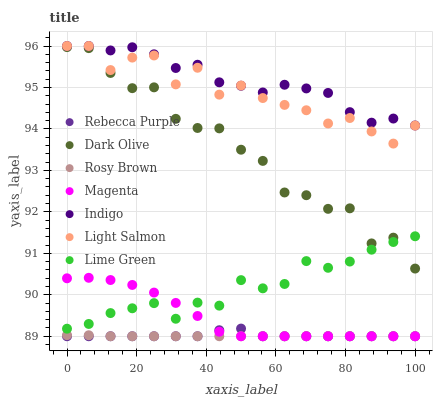Does Rosy Brown have the minimum area under the curve?
Answer yes or no. Yes. Does Indigo have the maximum area under the curve?
Answer yes or no. Yes. Does Dark Olive have the minimum area under the curve?
Answer yes or no. No. Does Dark Olive have the maximum area under the curve?
Answer yes or no. No. Is Rosy Brown the smoothest?
Answer yes or no. Yes. Is Light Salmon the roughest?
Answer yes or no. Yes. Is Dark Olive the smoothest?
Answer yes or no. No. Is Dark Olive the roughest?
Answer yes or no. No. Does Rosy Brown have the lowest value?
Answer yes or no. Yes. Does Dark Olive have the lowest value?
Answer yes or no. No. Does Indigo have the highest value?
Answer yes or no. Yes. Does Dark Olive have the highest value?
Answer yes or no. No. Is Rosy Brown less than Light Salmon?
Answer yes or no. Yes. Is Light Salmon greater than Rebecca Purple?
Answer yes or no. Yes. Does Magenta intersect Rebecca Purple?
Answer yes or no. Yes. Is Magenta less than Rebecca Purple?
Answer yes or no. No. Is Magenta greater than Rebecca Purple?
Answer yes or no. No. Does Rosy Brown intersect Light Salmon?
Answer yes or no. No. 